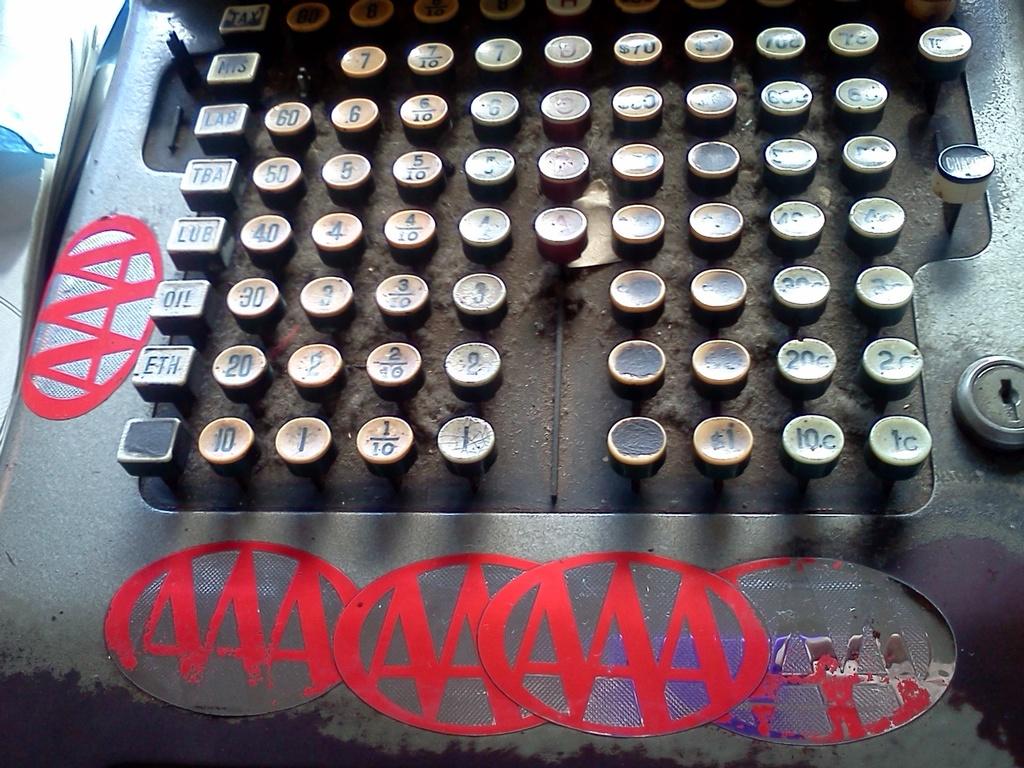What are the red letters?
Your answer should be very brief. Aaa. 